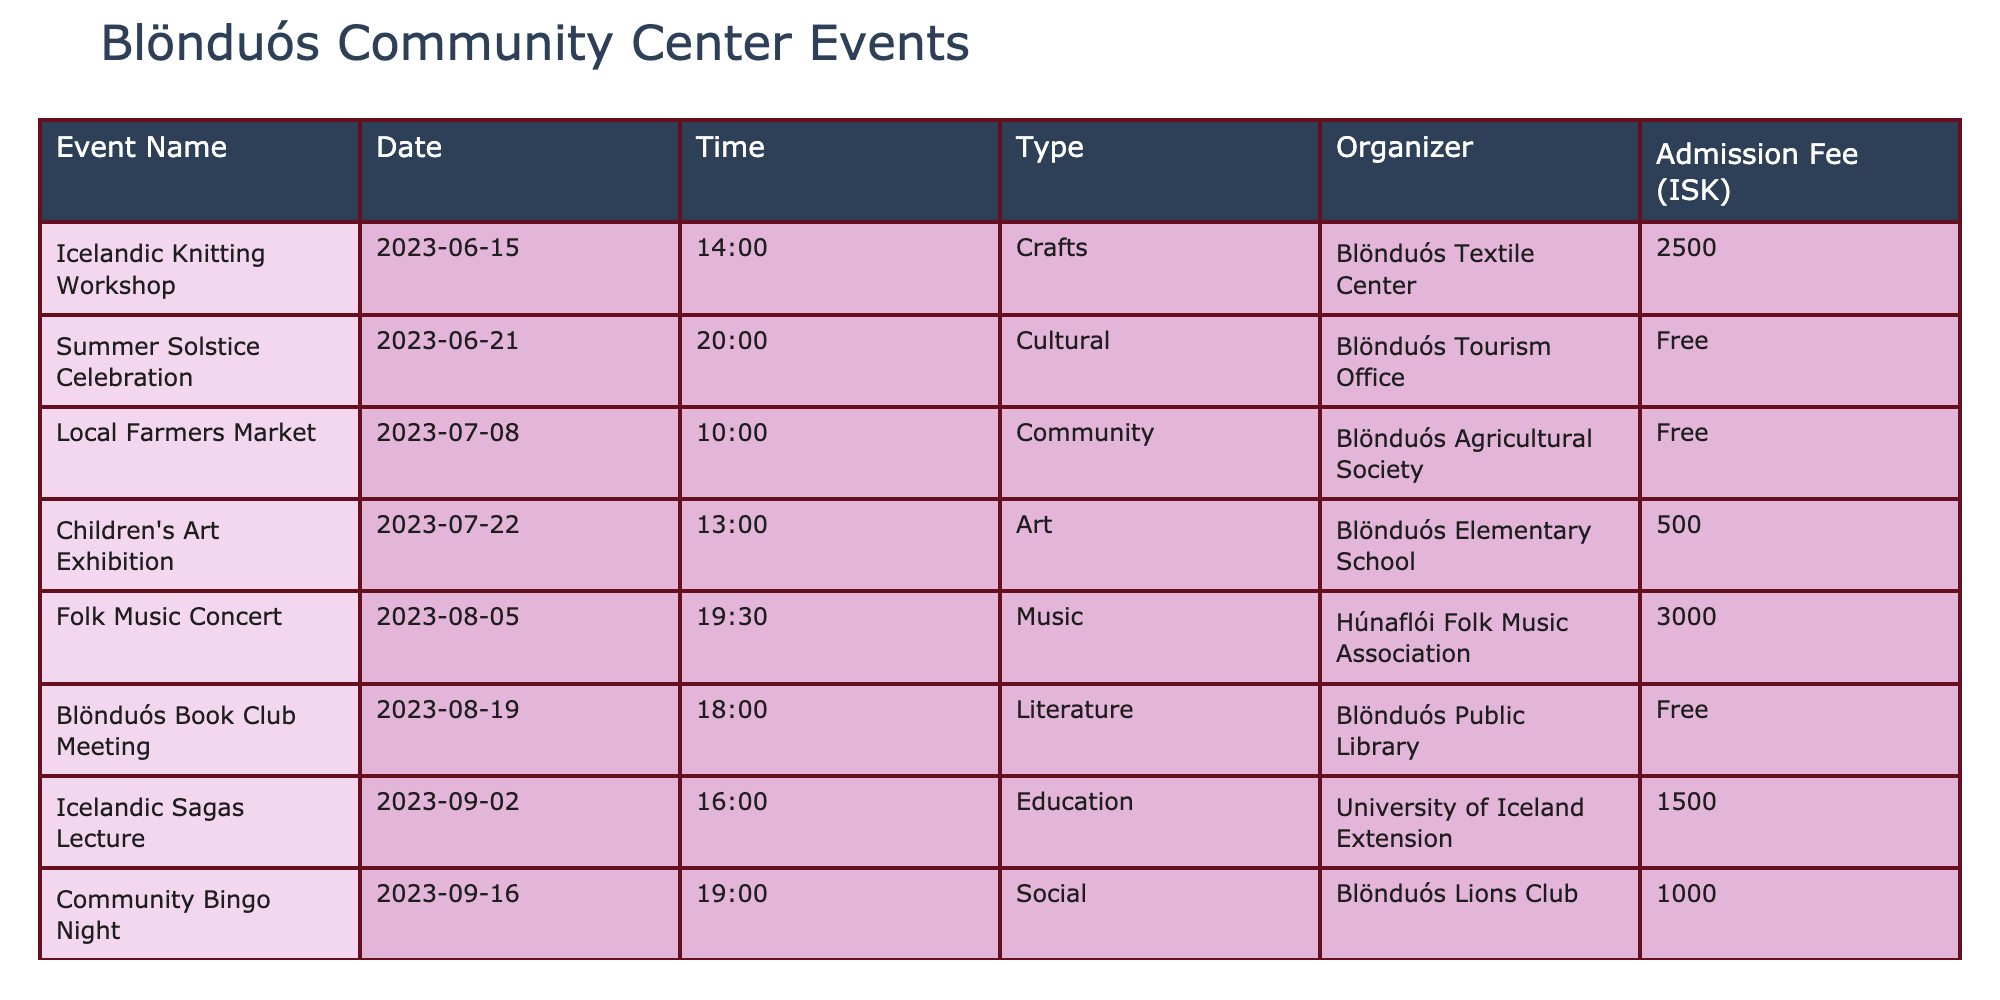What is the admission fee for the Icelandic Knitting Workshop? The admission fee for the Icelandic Knitting Workshop is listed in the table. Under the "Admission Fee (ISK)" column for this specific event, the fee is 2500 ISK.
Answer: 2500 ISK How many events are scheduled for August 2023? By looking at the table, I can count the events that are listed for the month of August. There are two events in August: the Folk Music Concert on August 5 and the Blönduós Book Club Meeting on August 19.
Answer: 2 Is the Summer Solstice Celebration free to attend? The table shows the admission fee for each event. For the Summer Solstice Celebration, it is marked as "Free," which indicates that there is no charge to attend.
Answer: Yes What type of events are organized by the Blönduós Agricultural Society? I look at the table for events organized by the Blönduós Agricultural Society. There is one event listed: the Local Farmers Market, categorized under "Community."
Answer: Community What is the total attendance fee for all the events that have an admission charge? First, I need to identify the events with admission fees, which are the Icelandic Knitting Workshop (2500 ISK), Folk Music Concert (3000 ISK), Children's Art Exhibition (500 ISK), Icelandic Sagas Lecture (1500 ISK), Community Bingo Night (1000 ISK), and Local History Presentation (1000 ISK). I then sum these fees: 2500 + 3000 + 500 + 1500 + 1000 + 1000 = 10000 ISK.
Answer: 10000 ISK When does the Autumn Equinox Nature Walk take place? The Autumn Equinox Nature Walk has a specific date (September 23) and time (15:00) noted in the table. Therefore, the event takes place on this date and time.
Answer: September 23, 15:00 Which event organized by the Blönduós Elementary School has the lowest admission fee? The table specifies events along with their admission fees. The event organized by Blönduós Elementary School is the Children's Art Exhibition, which has an admission fee of 500 ISK. This is the only event listed under this organizer, meaning it is the lowest by default.
Answer: 500 ISK Are there any outdoor events in the local events calendar? I check the table for any events categorized as "Outdoor." The only event listed under this category is the Autumn Equinox Nature Walk. Since it is present in the table, the answer to whether there are outdoor events is yes.
Answer: Yes How many events occur in September 2023? To find the number of events in September, I examine the table and count the events listed for that month. There are two events: the Icelandic Sagas Lecture on September 2 and the Community Bingo Night on September 16.
Answer: 2 What is the name of the organizer for the Children's Art Exhibition? The table shows the organizer for the Children's Art Exhibition under the "Organizer" column. According to the table, it is organized by Blönduós Elementary School.
Answer: Blönduós Elementary School 